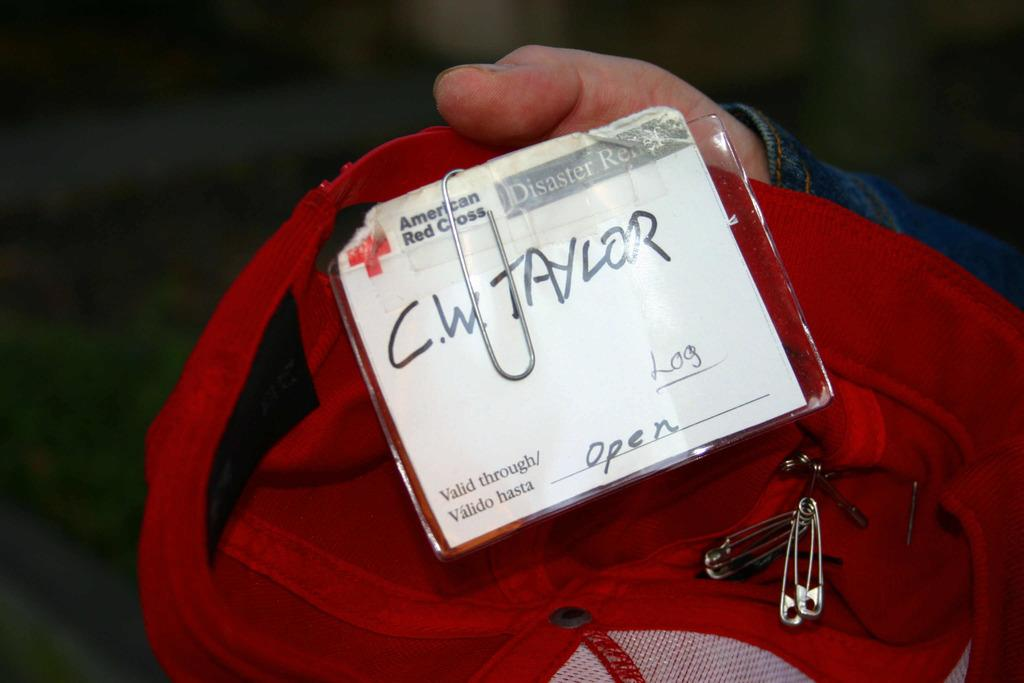What is the person in the image holding? The person is holding a bag in the image. What color is the bag? The bag is red in color. Are there any additional items attached to the bag? Yes, there is a pin attached to the bag. What is on the card that is on the bag? The card has the name "C. W. Taylor" written on it. How does the friction between the bag and the person's hand affect the wind in the image? There is no mention of friction or wind in the image, so it is not possible to determine their effects on each other. 